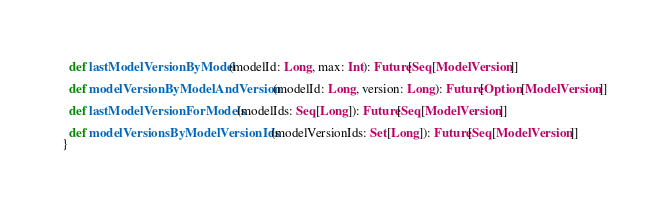<code> <loc_0><loc_0><loc_500><loc_500><_Scala_>  def lastModelVersionByModel(modelId: Long, max: Int): Future[Seq[ModelVersion]]

  def modelVersionByModelAndVersion(modelId: Long, version: Long): Future[Option[ModelVersion]]

  def lastModelVersionForModels(modelIds: Seq[Long]): Future[Seq[ModelVersion]]

  def modelVersionsByModelVersionIds(modelVersionIds: Set[Long]): Future[Seq[ModelVersion]]
}
</code> 